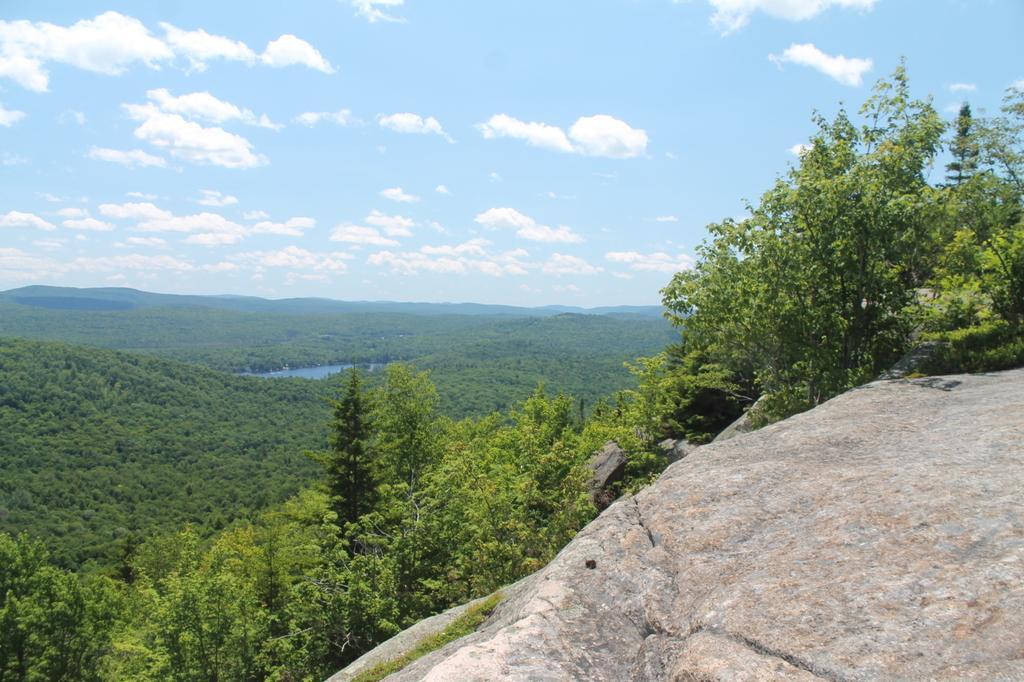In one or two sentences, can you explain what this image depicts? In this picture in the front there is a stone. In the center there are trees. There is water and the sky is cloudy. 